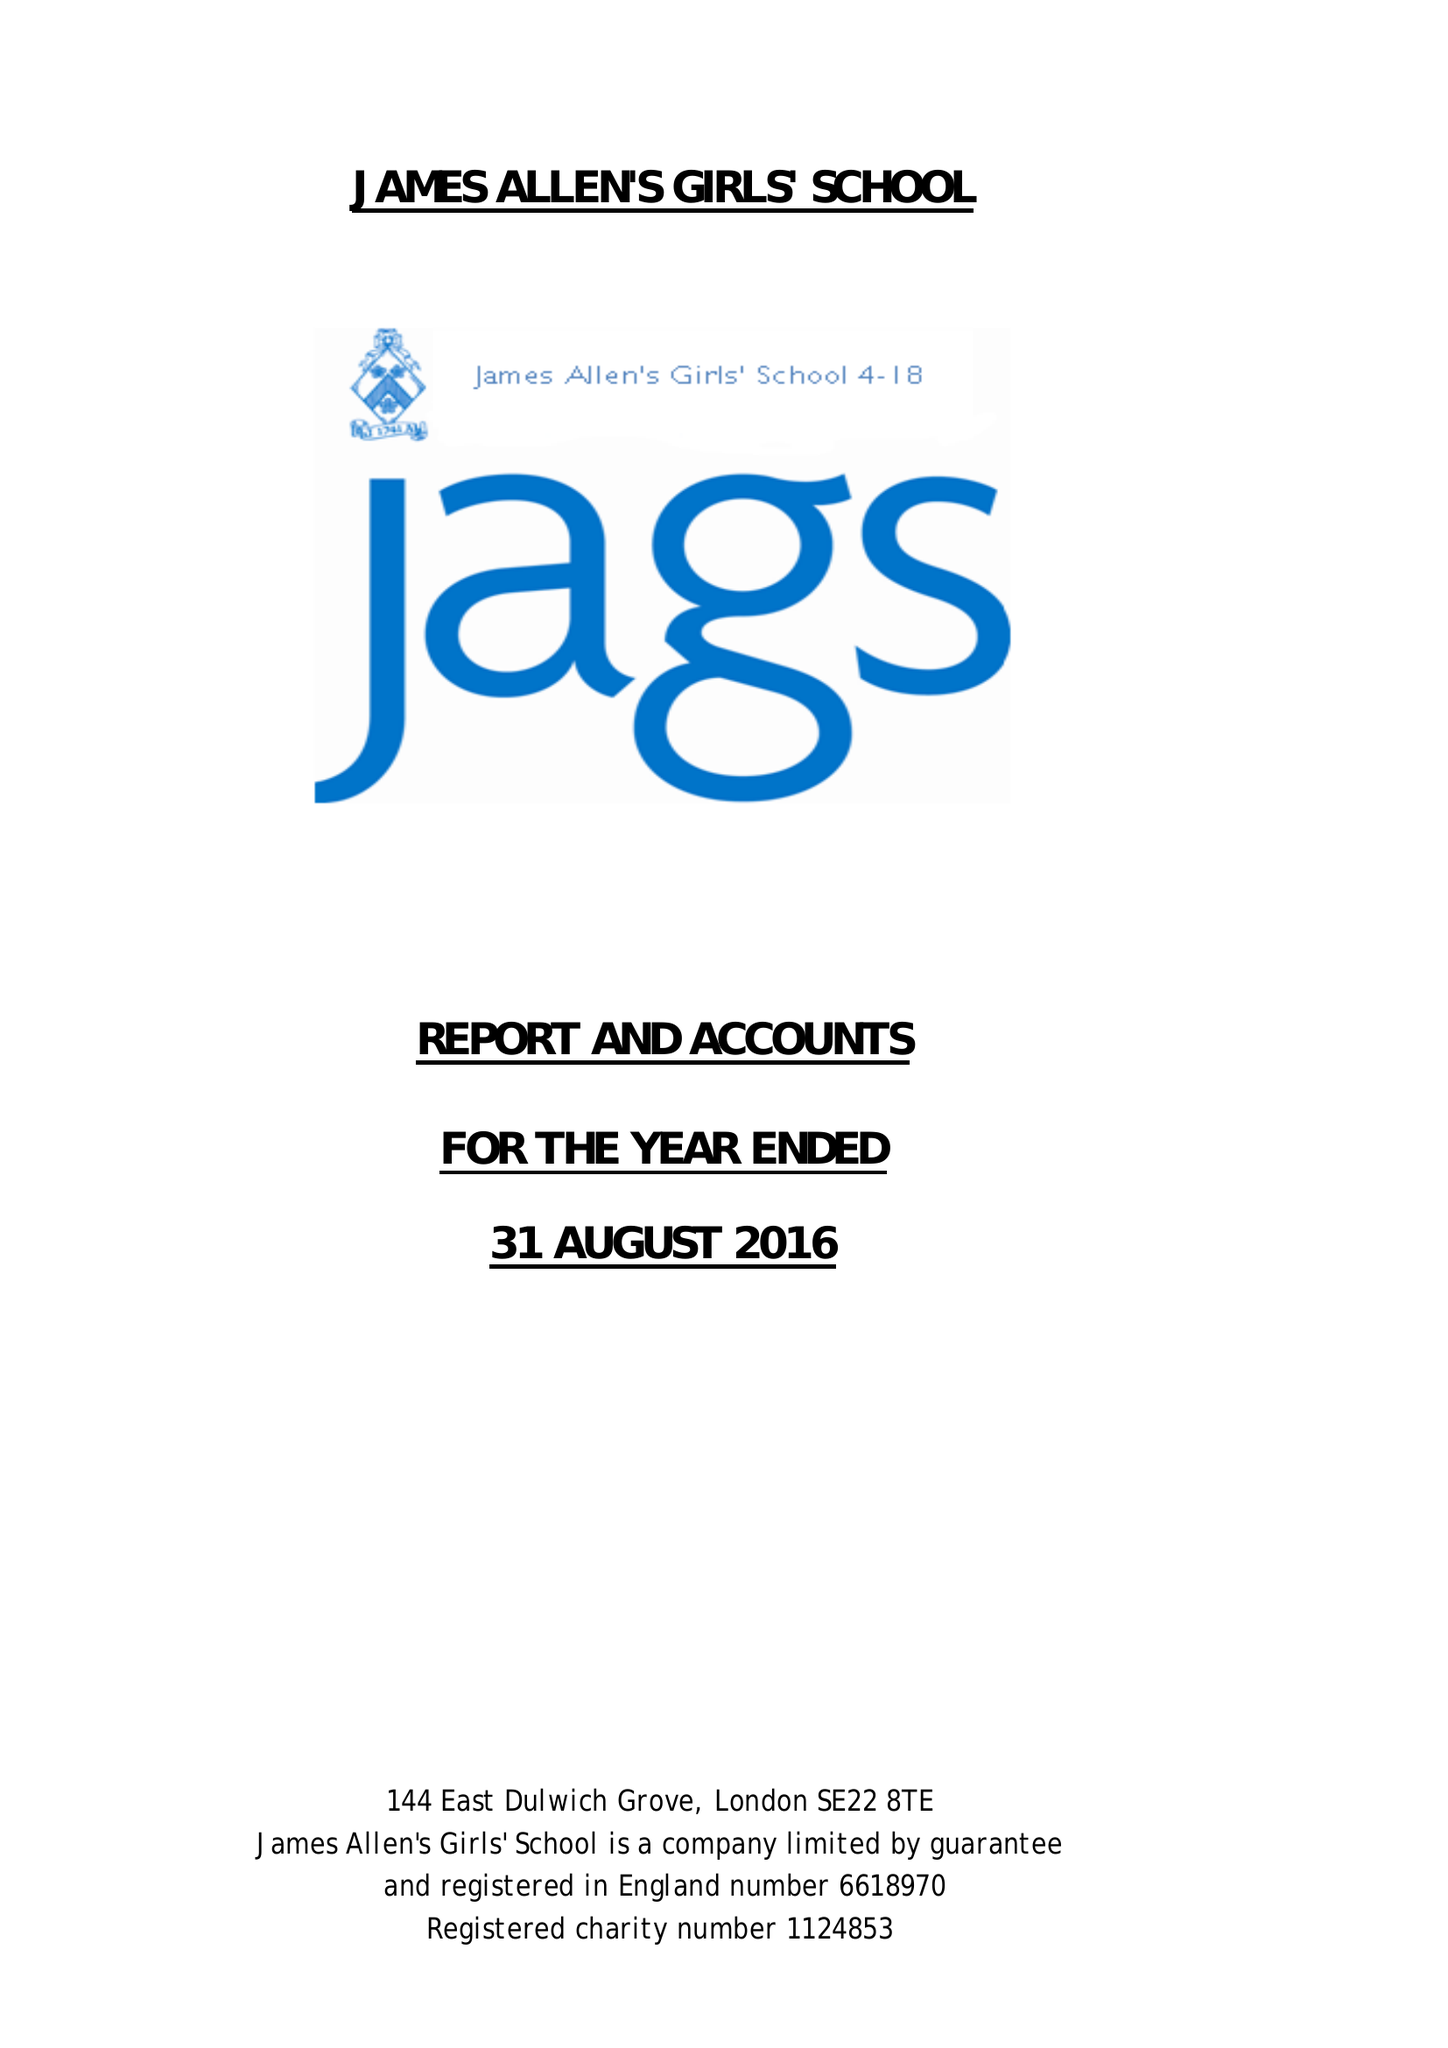What is the value for the report_date?
Answer the question using a single word or phrase. 2016-08-31 